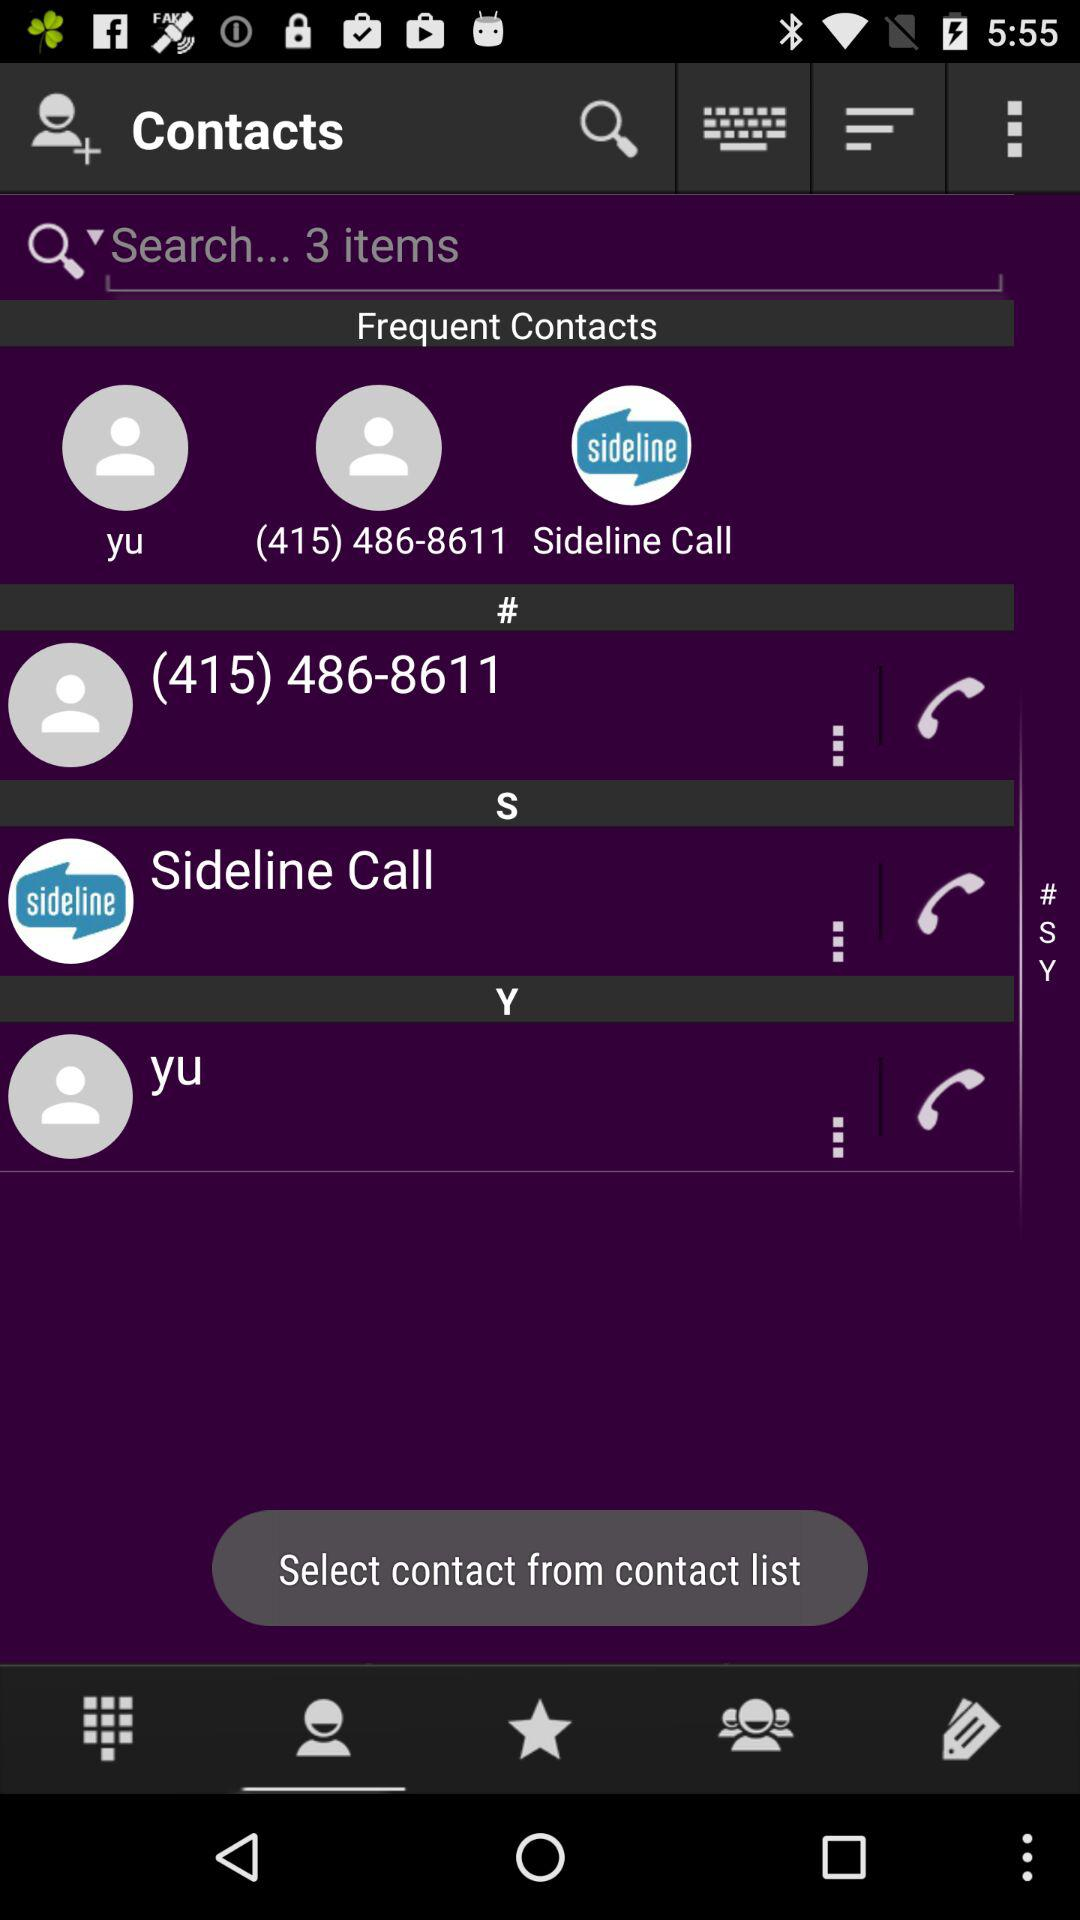What number is on the frequently called list? The number is (415) 486-8611. 